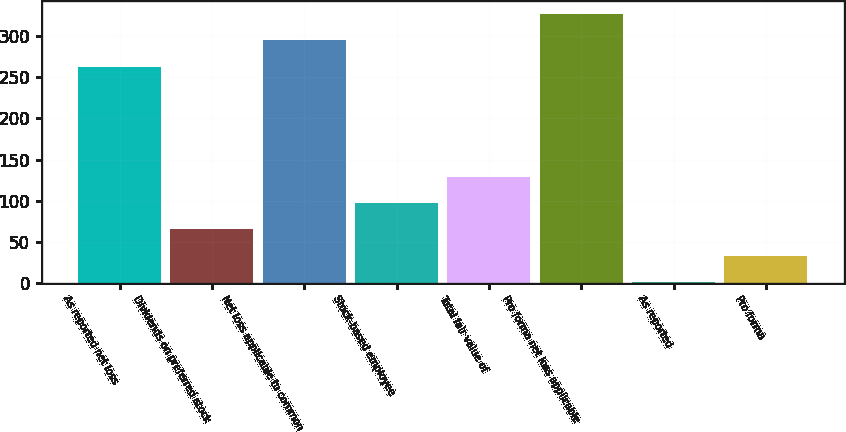<chart> <loc_0><loc_0><loc_500><loc_500><bar_chart><fcel>As reported net loss<fcel>Dividends on preferred stock<fcel>Net loss applicable to common<fcel>Stock-based employee<fcel>Total fair value of<fcel>Pro forma net loss applicable<fcel>As reported<fcel>Pro forma<nl><fcel>262.9<fcel>64.86<fcel>294.99<fcel>96.95<fcel>129.04<fcel>327.08<fcel>0.68<fcel>32.77<nl></chart> 